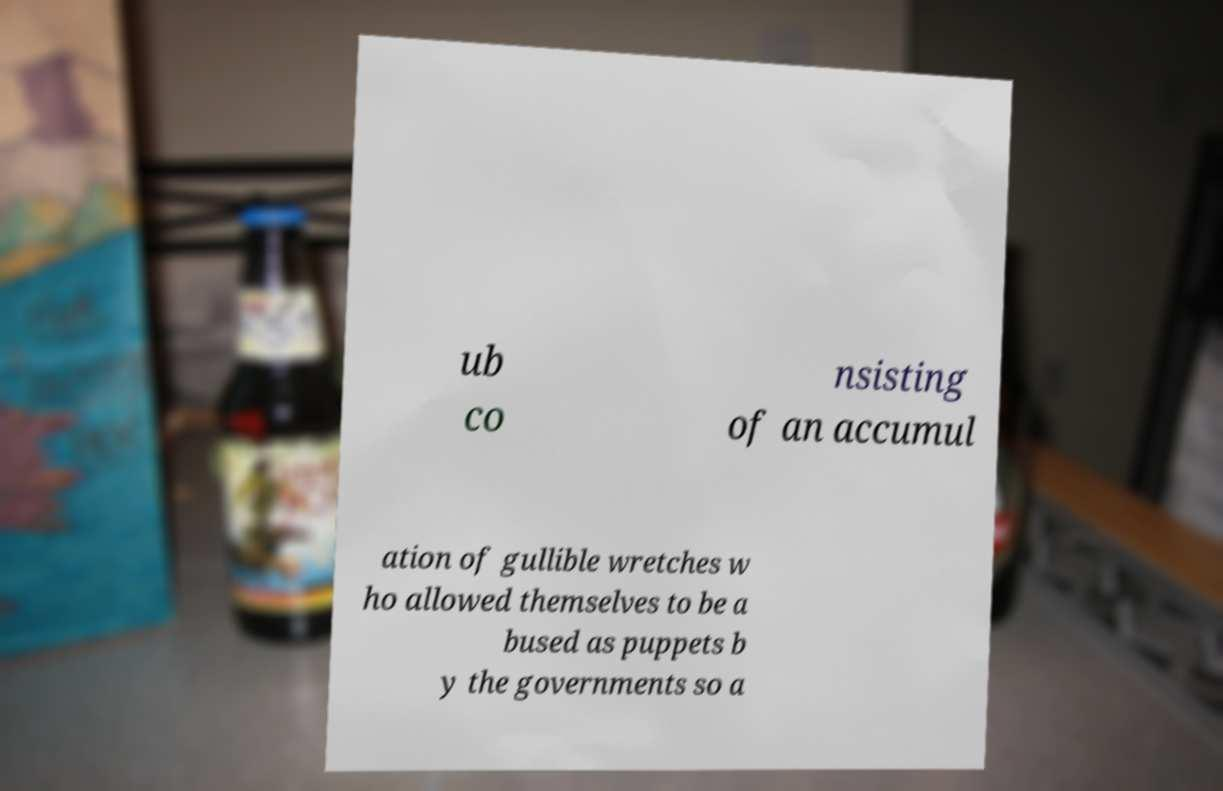Could you extract and type out the text from this image? ub co nsisting of an accumul ation of gullible wretches w ho allowed themselves to be a bused as puppets b y the governments so a 